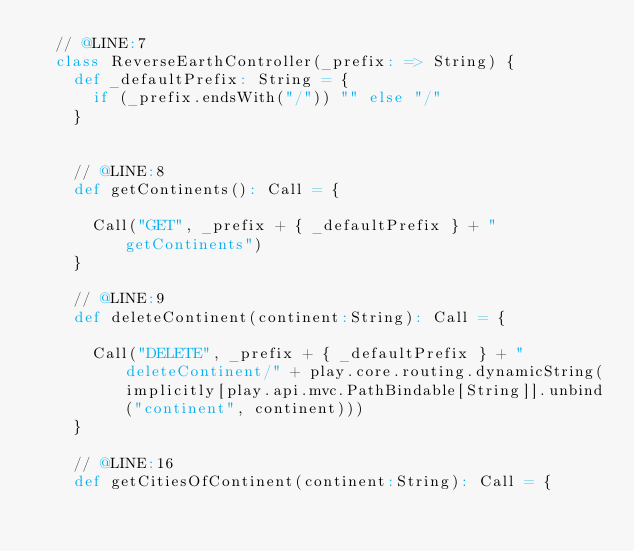<code> <loc_0><loc_0><loc_500><loc_500><_Scala_>  // @LINE:7
  class ReverseEarthController(_prefix: => String) {
    def _defaultPrefix: String = {
      if (_prefix.endsWith("/")) "" else "/"
    }

  
    // @LINE:8
    def getContinents(): Call = {
      
      Call("GET", _prefix + { _defaultPrefix } + "getContinents")
    }
  
    // @LINE:9
    def deleteContinent(continent:String): Call = {
      
      Call("DELETE", _prefix + { _defaultPrefix } + "deleteContinent/" + play.core.routing.dynamicString(implicitly[play.api.mvc.PathBindable[String]].unbind("continent", continent)))
    }
  
    // @LINE:16
    def getCitiesOfContinent(continent:String): Call = {
      </code> 